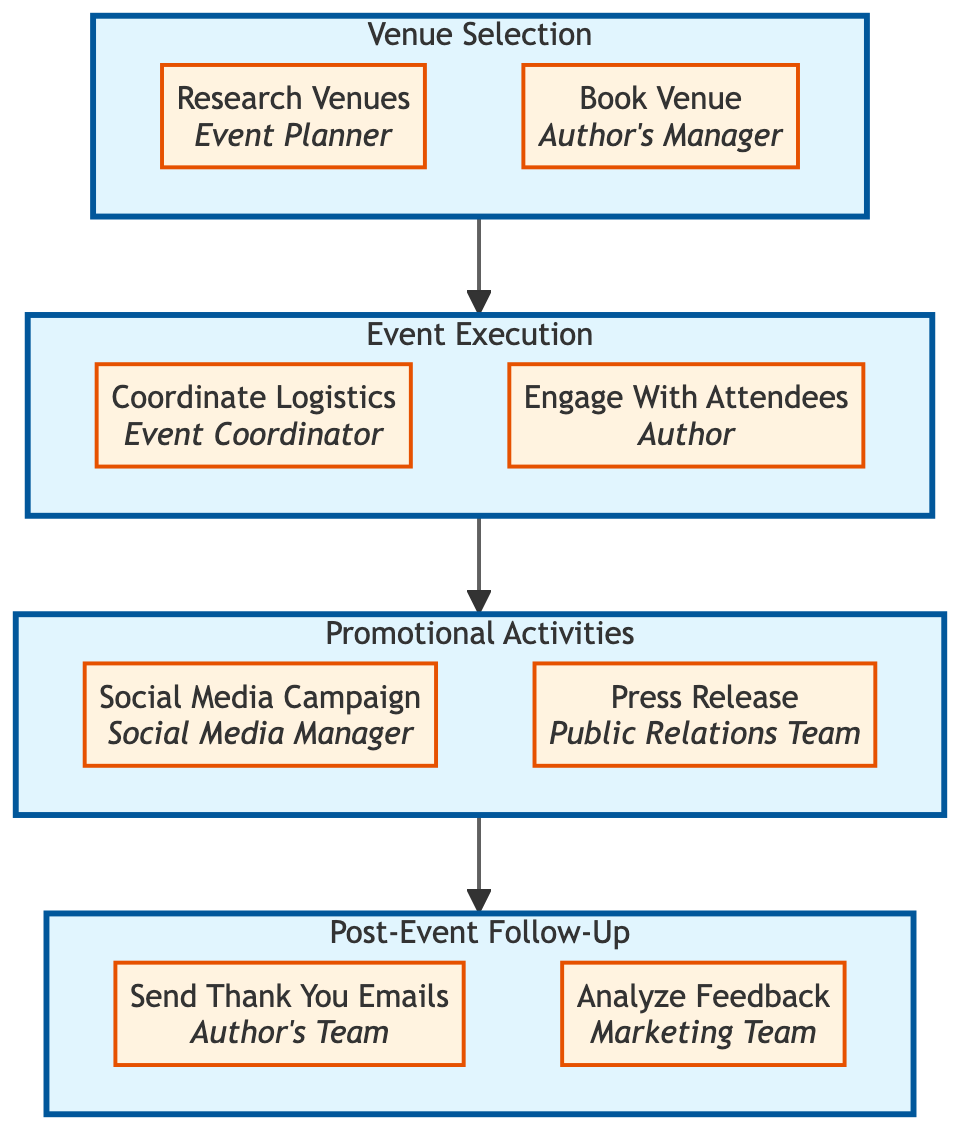What is the final step in the event planning workflow? The last step in the event planning workflow is "Send Thank You Emails," which falls under the "Post-Event Follow-Up" category. By tracing the connections upward from "Post-Event Follow-Up," this is the last box displayed in the diagram.
Answer: Send Thank You Emails Who is responsible for analyzing feedback? In the diagram, the task "Analyze Feedback" is assigned to the "Marketing Team," as indicated next to that specific node.
Answer: Marketing Team How many main categories are there in the event planning workflow? The diagram lists four main categories: "Venue Selection," "Event Execution," "Promotional Activities," and "Post-Event Follow-Up." By simply counting each main subgraph, we find there are four.
Answer: Four Which team coordinates logistics for the event? The "Coordinate Logistics" task is assigned to the "Event Coordinator," as specified in the node's description within the "Event Execution" category.
Answer: Event Coordinator What follows after "Promotional Activities"? According to the flow direction indicated in the diagram, "Post-Event Follow-Up" is the step that follows after completing "Promotional Activities." This shows the sequence of tasks from one category to the next.
Answer: Post-Event Follow-Up What is the first task after venue selection? The first task after "Venue Selection" is "Coordinate Logistics," which signifies that once a venue is booked, logistics for the event will be coordinated next. This is visible as the direct successor node in the flow.
Answer: Coordinate Logistics Who leads the social media campaign? The responsibility for the "Social Media Campaign" falls to the "Social Media Manager," as indicated in the node assigned to that task under "Promotional Activities."
Answer: Social Media Manager How many tasks are there under the "Event Execution" category? Under "Event Execution," there are two tasks listed: "Coordinate Logistics" and "Engage With Attendees." Counting these tasks within the category gives us a total of two.
Answer: Two What is the primary function of the "Research Venues" task? The "Research Venues" task is focused on identifying potential venues that fit the book's theme and expected audience size, as described in its respective node within the "Venue Selection" category.
Answer: Identify potential venues 